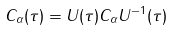Convert formula to latex. <formula><loc_0><loc_0><loc_500><loc_500>C _ { \alpha } ( \tau ) = U ( \tau ) C _ { \alpha } U ^ { - 1 } ( \tau )</formula> 